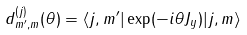<formula> <loc_0><loc_0><loc_500><loc_500>d ^ { ( j ) } _ { m ^ { \prime } , m } ( \theta ) = \langle j , m ^ { \prime } | \exp ( - i \theta J _ { y } ) | j , m \rangle</formula> 